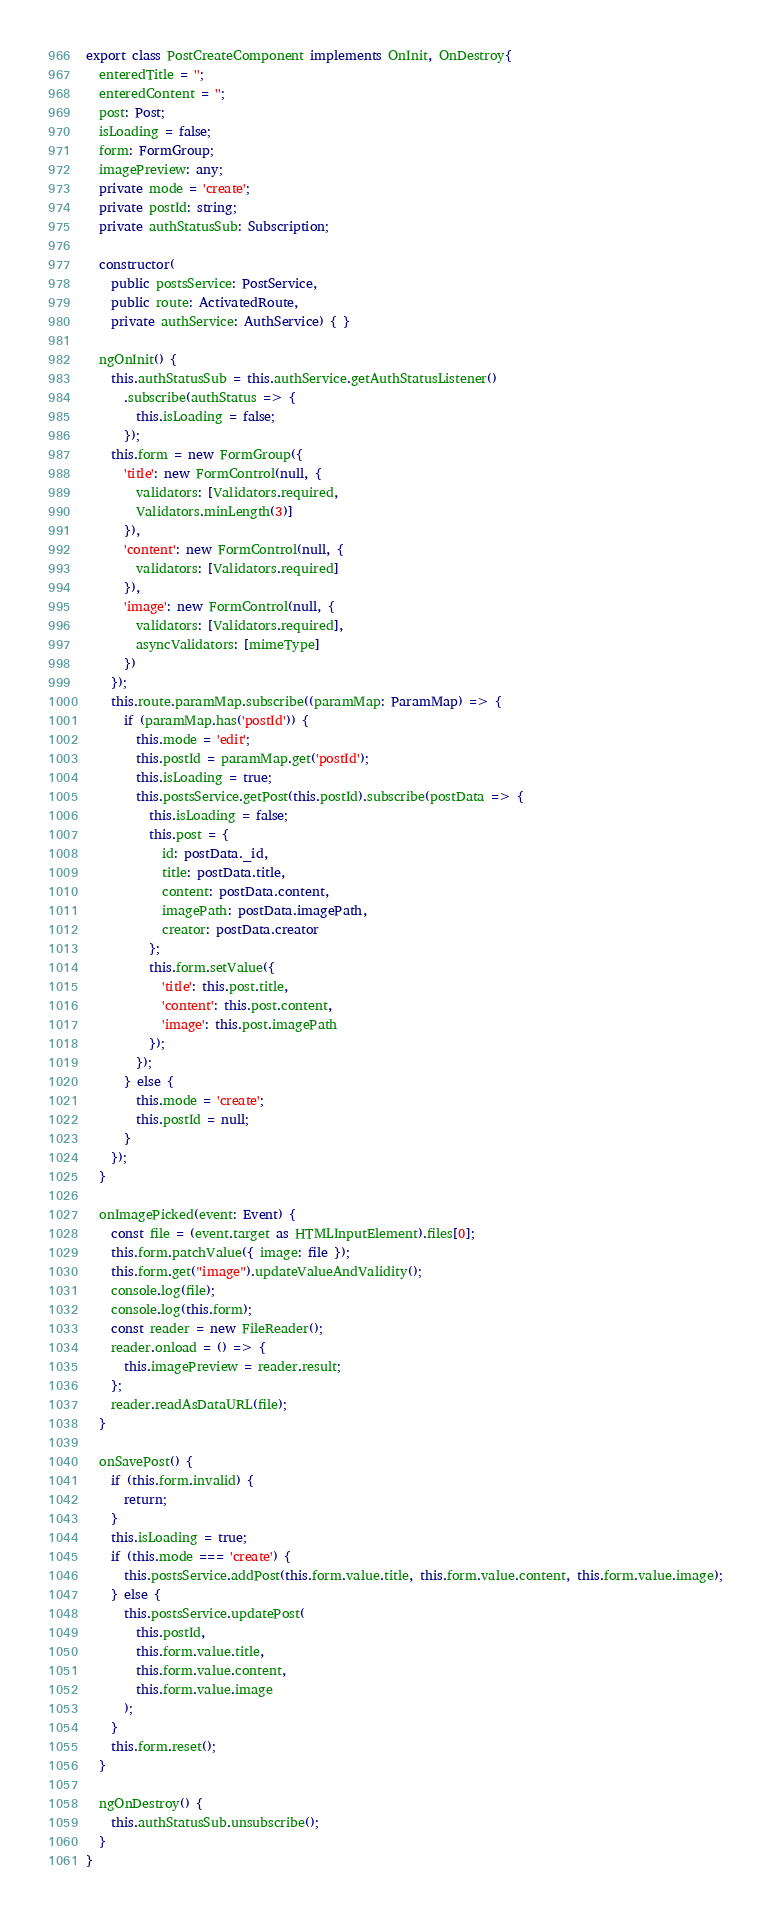Convert code to text. <code><loc_0><loc_0><loc_500><loc_500><_TypeScript_>export class PostCreateComponent implements OnInit, OnDestroy{
  enteredTitle = '';
  enteredContent = '';
  post: Post;
  isLoading = false;
  form: FormGroup;
  imagePreview: any;
  private mode = 'create';
  private postId: string;
  private authStatusSub: Subscription;

  constructor(
    public postsService: PostService,
    public route: ActivatedRoute,
    private authService: AuthService) { }

  ngOnInit() {
    this.authStatusSub = this.authService.getAuthStatusListener()
      .subscribe(authStatus => {
        this.isLoading = false;
      });
    this.form = new FormGroup({
      'title': new FormControl(null, {
        validators: [Validators.required,
        Validators.minLength(3)]
      }),
      'content': new FormControl(null, {
        validators: [Validators.required]
      }),
      'image': new FormControl(null, {
        validators: [Validators.required],
        asyncValidators: [mimeType]
      })
    });
    this.route.paramMap.subscribe((paramMap: ParamMap) => {
      if (paramMap.has('postId')) {
        this.mode = 'edit';
        this.postId = paramMap.get('postId');
        this.isLoading = true;
        this.postsService.getPost(this.postId).subscribe(postData => {
          this.isLoading = false;
          this.post = {
            id: postData._id,
            title: postData.title,
            content: postData.content,
            imagePath: postData.imagePath,
            creator: postData.creator
          };
          this.form.setValue({
            'title': this.post.title,
            'content': this.post.content,
            'image': this.post.imagePath
          });
        });
      } else {
        this.mode = 'create';
        this.postId = null;
      }
    });
  }

  onImagePicked(event: Event) {
    const file = (event.target as HTMLInputElement).files[0];
    this.form.patchValue({ image: file });
    this.form.get("image").updateValueAndValidity();
    console.log(file);
    console.log(this.form);
    const reader = new FileReader();
    reader.onload = () => {
      this.imagePreview = reader.result;
    };
    reader.readAsDataURL(file);
  }

  onSavePost() {
    if (this.form.invalid) {
      return;
    }
    this.isLoading = true;
    if (this.mode === 'create') {
      this.postsService.addPost(this.form.value.title, this.form.value.content, this.form.value.image);
    } else {
      this.postsService.updatePost(
        this.postId,
        this.form.value.title,
        this.form.value.content,
        this.form.value.image
      );
    }
    this.form.reset();
  }

  ngOnDestroy() {
    this.authStatusSub.unsubscribe();
  }
}
</code> 